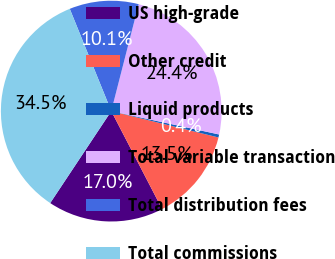Convert chart to OTSL. <chart><loc_0><loc_0><loc_500><loc_500><pie_chart><fcel>US high-grade<fcel>Other credit<fcel>Liquid products<fcel>Total variable transaction<fcel>Total distribution fees<fcel>Total commissions<nl><fcel>16.95%<fcel>13.54%<fcel>0.44%<fcel>24.4%<fcel>10.13%<fcel>34.53%<nl></chart> 